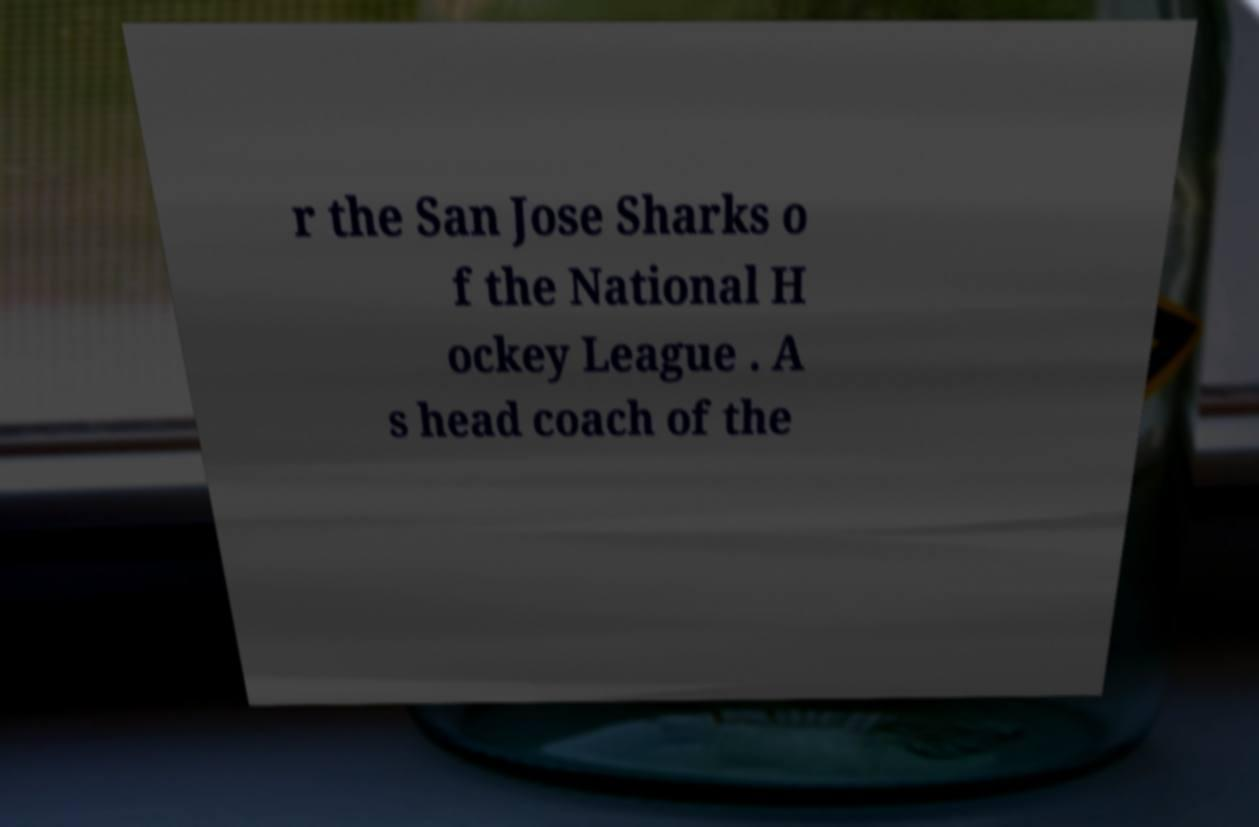Can you accurately transcribe the text from the provided image for me? r the San Jose Sharks o f the National H ockey League . A s head coach of the 